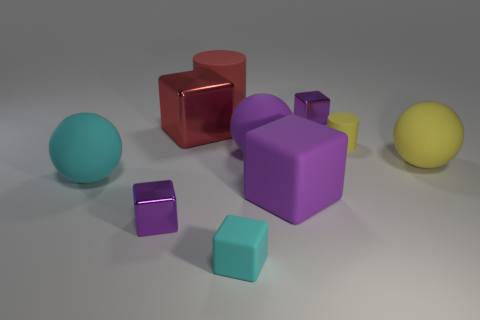There is a big rubber cylinder; is its color the same as the big cube that is left of the big purple sphere?
Provide a short and direct response. Yes. Does the matte sphere that is behind the yellow ball have the same color as the large matte cube?
Ensure brevity in your answer.  Yes. Is the color of the large metallic block the same as the big cylinder?
Your answer should be very brief. Yes. How many purple things are the same shape as the big cyan matte thing?
Ensure brevity in your answer.  1. There is a red thing that is made of the same material as the small cyan object; what size is it?
Give a very brief answer. Large. What is the color of the shiny object that is on the left side of the large matte cube and behind the big cyan rubber thing?
Make the answer very short. Red. What number of cyan rubber objects are the same size as the red cylinder?
Your answer should be compact. 1. There is a thing that is the same color as the large rubber cylinder; what size is it?
Ensure brevity in your answer.  Large. There is a ball that is both on the right side of the big cyan thing and left of the tiny yellow cylinder; what is its size?
Give a very brief answer. Large. How many purple rubber spheres are behind the rubber object that is behind the tiny purple metallic thing that is behind the yellow cylinder?
Provide a succinct answer. 0. 